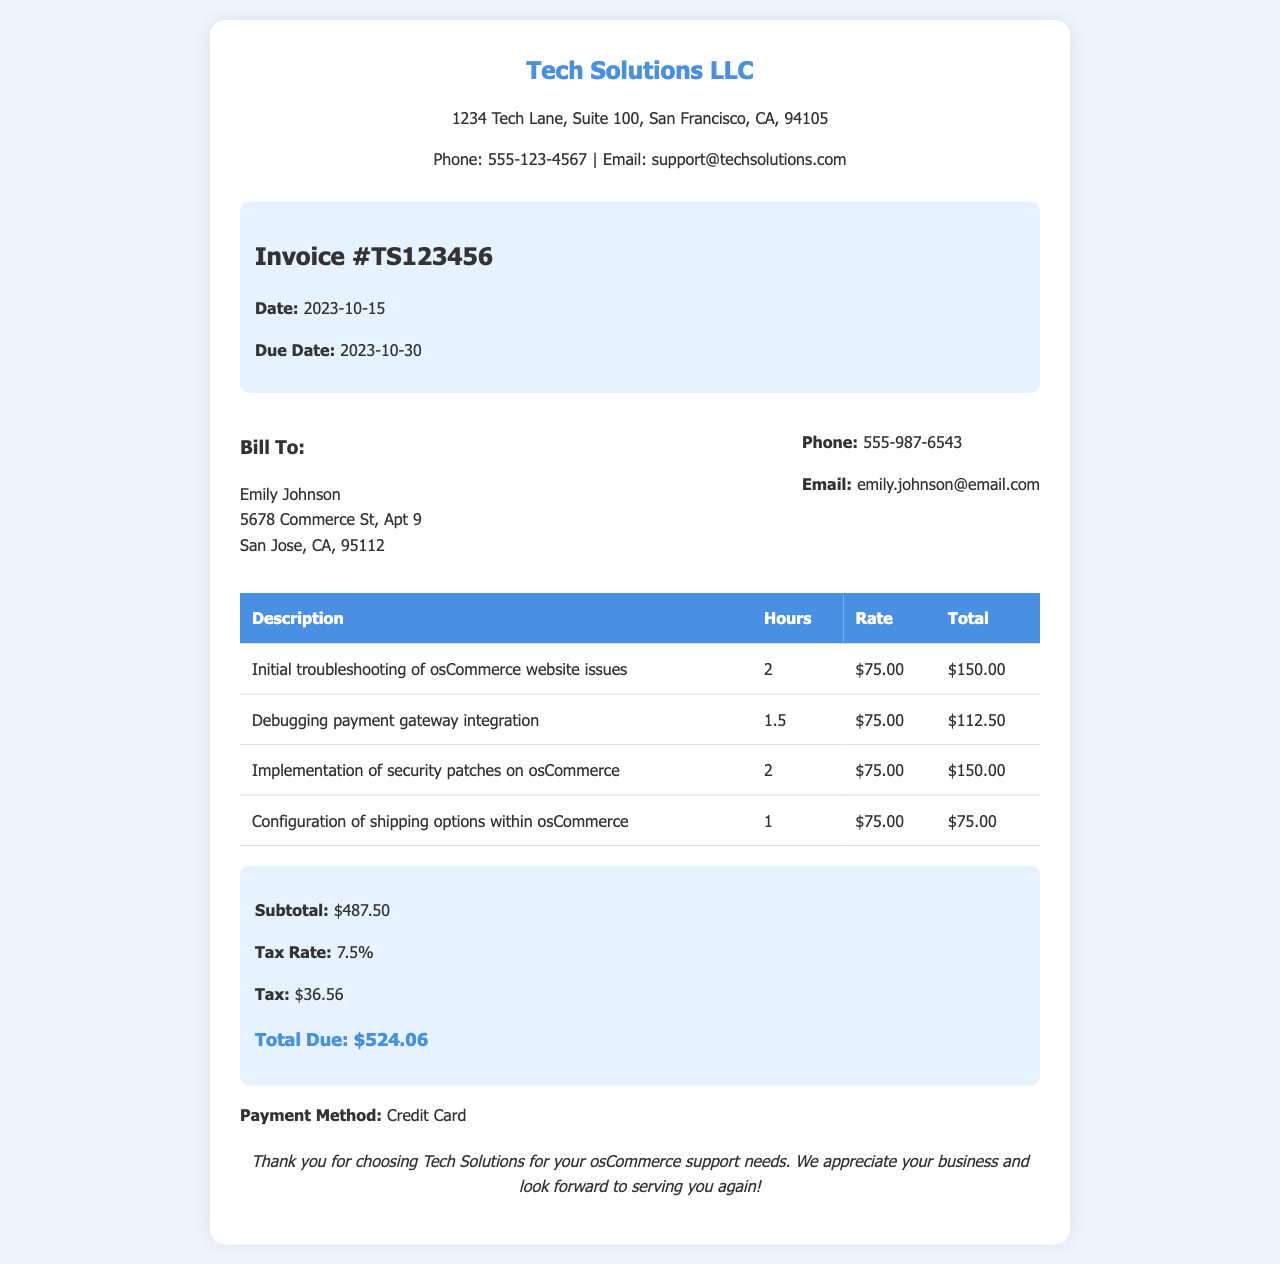What is the invoice number? The invoice number is a unique identifier assigned to the receipt, which is found in the invoice details section.
Answer: TS123456 What is the due date for this receipt? The due date is the date by which the payment should be made, located in the invoice details.
Answer: 2023-10-30 How many hours were spent on debugging payment gateway integration? The hours spent on a specific task are listed in the table under the 'Hours' column for each service description.
Answer: 1.5 What is the total due amount? The total amount due is the final figure calculated after adding the subtotal and tax, found at the bottom of the summary section.
Answer: $524.06 What is the tax rate applied? The tax rate is specified in the summary section of the receipt.
Answer: 7.5% Who is the receipt billed to? The customer's name who is billed for the services is found in the customer info section.
Answer: Emily Johnson What was the first service listed in the table? The first service listed in the table provides a description of the work performed and can be found in the first row of the table.
Answer: Initial troubleshooting of osCommerce website issues What is the subtotal before tax? The subtotal is the sum of all charges before tax is added, which can be found in the summary section of the receipt.
Answer: $487.50 What payment method was used? The payment method indicates how payment was made and is stated at the bottom of the receipt.
Answer: Credit Card 